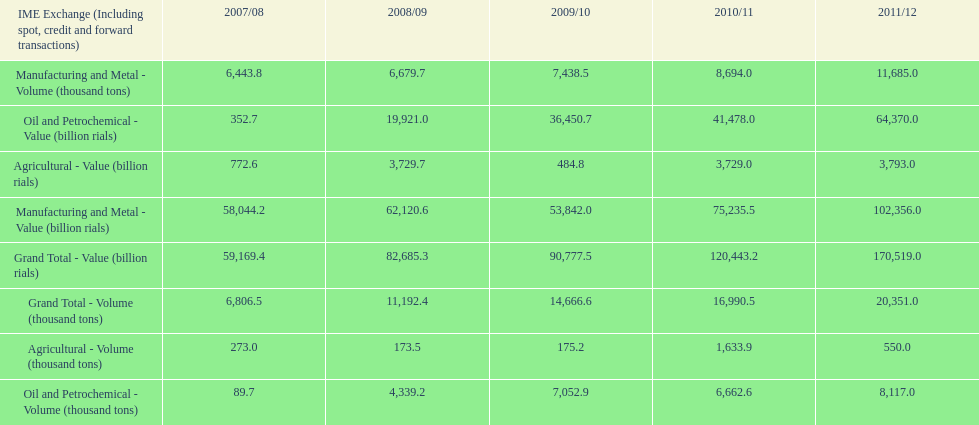In how many years was the value of agriculture, in billion rials, greater than 500 in iran? 4. 